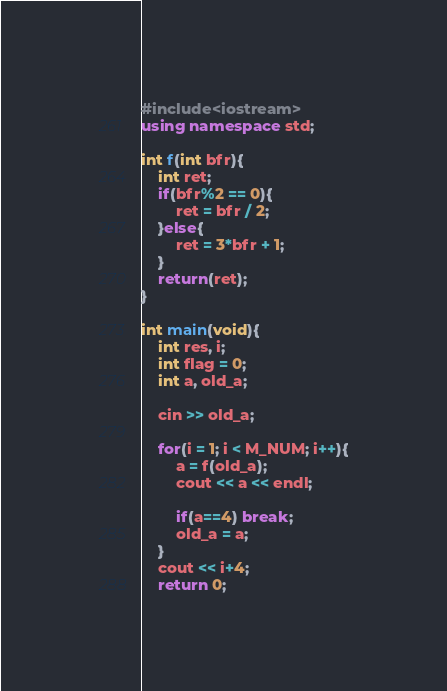Convert code to text. <code><loc_0><loc_0><loc_500><loc_500><_C++_>#include<iostream>
using namespace std;

int f(int bfr){
    int ret;
    if(bfr%2 == 0){
        ret = bfr / 2;
    }else{
        ret = 3*bfr + 1;
    }
    return(ret);
}

int main(void){
    int res, i;
    int flag = 0;
    int a, old_a;

    cin >> old_a;

    for(i = 1; i < M_NUM; i++){
        a = f(old_a);
        cout << a << endl;

        if(a==4) break;
        old_a = a;
    }
    cout << i+4;
    return 0;</code> 